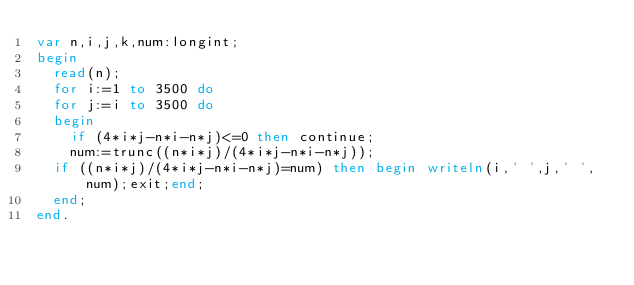<code> <loc_0><loc_0><loc_500><loc_500><_Pascal_>var n,i,j,k,num:longint;
begin
  read(n);
  for i:=1 to 3500 do
  for j:=i to 3500 do
  begin
    if (4*i*j-n*i-n*j)<=0 then continue;
    num:=trunc((n*i*j)/(4*i*j-n*i-n*j));
  if ((n*i*j)/(4*i*j-n*i-n*j)=num) then begin writeln(i,' ',j,' ',num);exit;end;
  end;
end.</code> 